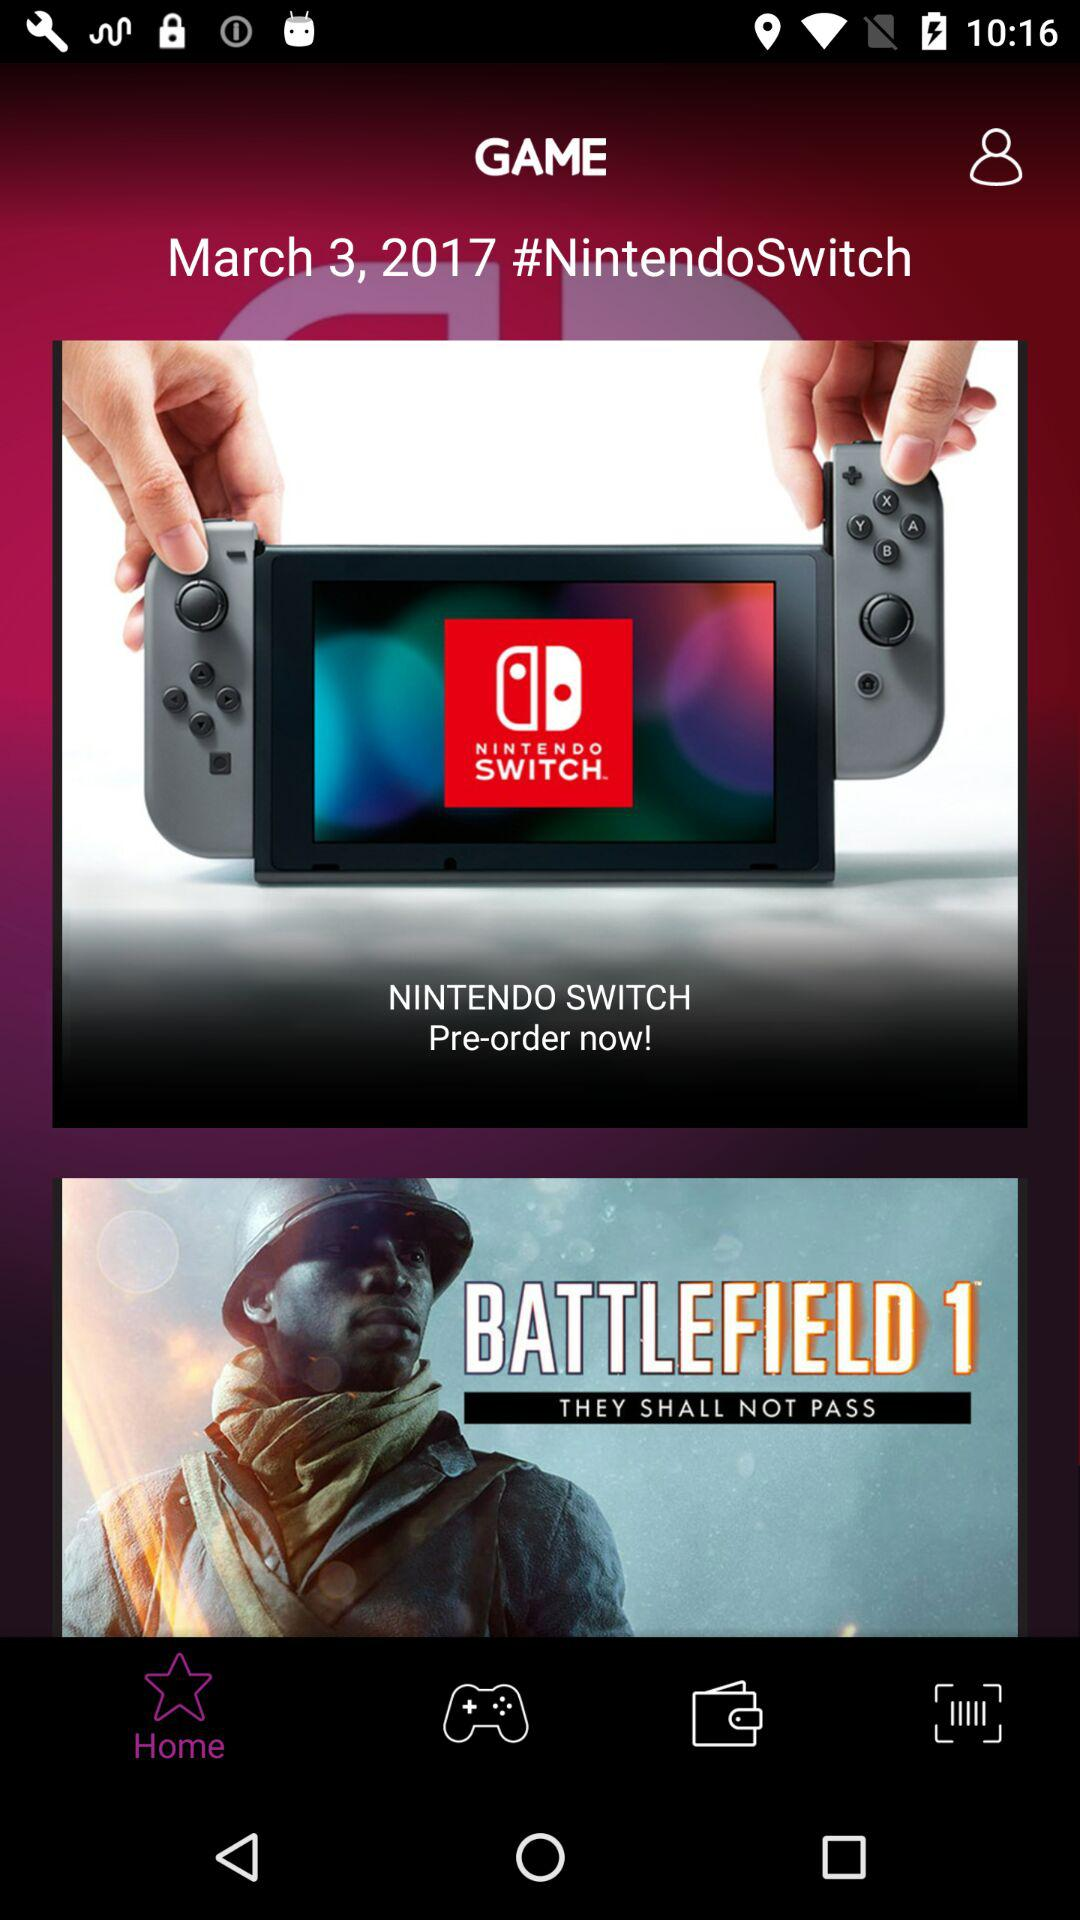What is the given date? The given date is March 3, 2017. 